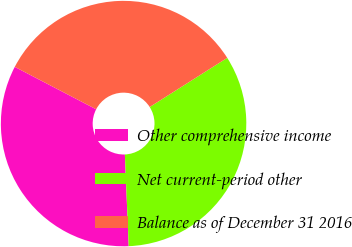Convert chart. <chart><loc_0><loc_0><loc_500><loc_500><pie_chart><fcel>Other comprehensive income<fcel>Net current-period other<fcel>Balance as of December 31 2016<nl><fcel>33.31%<fcel>33.33%<fcel>33.36%<nl></chart> 